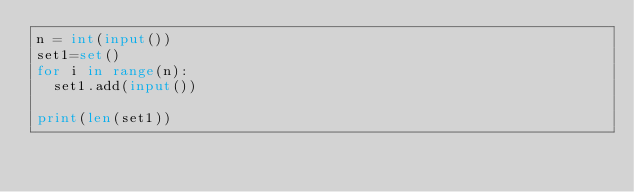Convert code to text. <code><loc_0><loc_0><loc_500><loc_500><_Python_>n = int(input())
set1=set()
for i in range(n):
  set1.add(input())
  
print(len(set1))</code> 